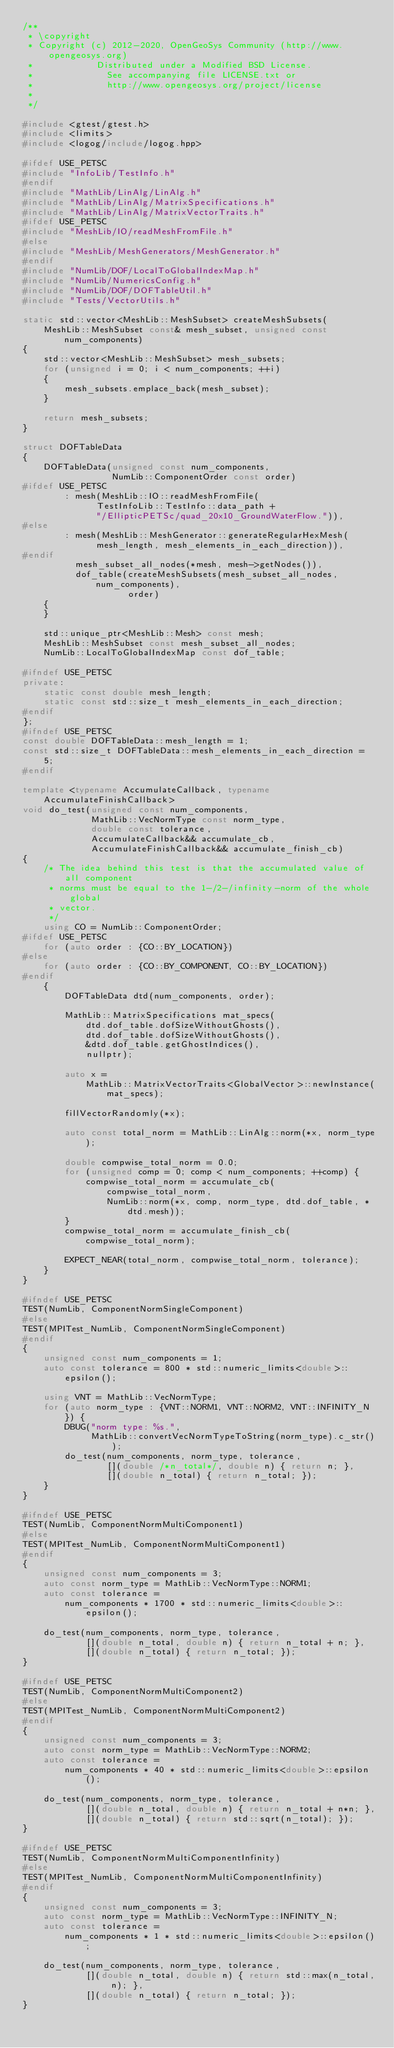<code> <loc_0><loc_0><loc_500><loc_500><_C++_>/**
 * \copyright
 * Copyright (c) 2012-2020, OpenGeoSys Community (http://www.opengeosys.org)
 *            Distributed under a Modified BSD License.
 *              See accompanying file LICENSE.txt or
 *              http://www.opengeosys.org/project/license
 *
 */

#include <gtest/gtest.h>
#include <limits>
#include <logog/include/logog.hpp>

#ifdef USE_PETSC
#include "InfoLib/TestInfo.h"
#endif
#include "MathLib/LinAlg/LinAlg.h"
#include "MathLib/LinAlg/MatrixSpecifications.h"
#include "MathLib/LinAlg/MatrixVectorTraits.h"
#ifdef USE_PETSC
#include "MeshLib/IO/readMeshFromFile.h"
#else
#include "MeshLib/MeshGenerators/MeshGenerator.h"
#endif
#include "NumLib/DOF/LocalToGlobalIndexMap.h"
#include "NumLib/NumericsConfig.h"
#include "NumLib/DOF/DOFTableUtil.h"
#include "Tests/VectorUtils.h"

static std::vector<MeshLib::MeshSubset> createMeshSubsets(
    MeshLib::MeshSubset const& mesh_subset, unsigned const num_components)
{
    std::vector<MeshLib::MeshSubset> mesh_subsets;
    for (unsigned i = 0; i < num_components; ++i)
    {
        mesh_subsets.emplace_back(mesh_subset);
    }

    return mesh_subsets;
}

struct DOFTableData
{
    DOFTableData(unsigned const num_components,
                 NumLib::ComponentOrder const order)
#ifdef USE_PETSC
        : mesh(MeshLib::IO::readMeshFromFile(
              TestInfoLib::TestInfo::data_path +
              "/EllipticPETSc/quad_20x10_GroundWaterFlow.")),
#else
        : mesh(MeshLib::MeshGenerator::generateRegularHexMesh(
              mesh_length, mesh_elements_in_each_direction)),
#endif
          mesh_subset_all_nodes(*mesh, mesh->getNodes()),
          dof_table(createMeshSubsets(mesh_subset_all_nodes, num_components),
                    order)
    {
    }

    std::unique_ptr<MeshLib::Mesh> const mesh;
    MeshLib::MeshSubset const mesh_subset_all_nodes;
    NumLib::LocalToGlobalIndexMap const dof_table;

#ifndef USE_PETSC
private:
    static const double mesh_length;
    static const std::size_t mesh_elements_in_each_direction;
#endif
};
#ifndef USE_PETSC
const double DOFTableData::mesh_length = 1;
const std::size_t DOFTableData::mesh_elements_in_each_direction = 5;
#endif

template <typename AccumulateCallback, typename AccumulateFinishCallback>
void do_test(unsigned const num_components,
             MathLib::VecNormType const norm_type,
             double const tolerance,
             AccumulateCallback&& accumulate_cb,
             AccumulateFinishCallback&& accumulate_finish_cb)
{
    /* The idea behind this test is that the accumulated value of all component
     * norms must be equal to the 1-/2-/infinity-norm of the whole global
     * vector.
     */
    using CO = NumLib::ComponentOrder;
#ifdef USE_PETSC
    for (auto order : {CO::BY_LOCATION})
#else
    for (auto order : {CO::BY_COMPONENT, CO::BY_LOCATION})
#endif
    {
        DOFTableData dtd(num_components, order);

        MathLib::MatrixSpecifications mat_specs(
            dtd.dof_table.dofSizeWithoutGhosts(),
            dtd.dof_table.dofSizeWithoutGhosts(),
            &dtd.dof_table.getGhostIndices(),
            nullptr);

        auto x =
            MathLib::MatrixVectorTraits<GlobalVector>::newInstance(mat_specs);

        fillVectorRandomly(*x);

        auto const total_norm = MathLib::LinAlg::norm(*x, norm_type);

        double compwise_total_norm = 0.0;
        for (unsigned comp = 0; comp < num_components; ++comp) {
            compwise_total_norm = accumulate_cb(
                compwise_total_norm,
                NumLib::norm(*x, comp, norm_type, dtd.dof_table, *dtd.mesh));
        }
        compwise_total_norm = accumulate_finish_cb(compwise_total_norm);

        EXPECT_NEAR(total_norm, compwise_total_norm, tolerance);
    }
}

#ifndef USE_PETSC
TEST(NumLib, ComponentNormSingleComponent)
#else
TEST(MPITest_NumLib, ComponentNormSingleComponent)
#endif
{
    unsigned const num_components = 1;
    auto const tolerance = 800 * std::numeric_limits<double>::epsilon();

    using VNT = MathLib::VecNormType;
    for (auto norm_type : {VNT::NORM1, VNT::NORM2, VNT::INFINITY_N}) {
        DBUG("norm type: %s.",
             MathLib::convertVecNormTypeToString(norm_type).c_str());
        do_test(num_components, norm_type, tolerance,
                [](double /*n_total*/, double n) { return n; },
                [](double n_total) { return n_total; });
    }
}

#ifndef USE_PETSC
TEST(NumLib, ComponentNormMultiComponent1)
#else
TEST(MPITest_NumLib, ComponentNormMultiComponent1)
#endif
{
    unsigned const num_components = 3;
    auto const norm_type = MathLib::VecNormType::NORM1;
    auto const tolerance =
        num_components * 1700 * std::numeric_limits<double>::epsilon();

    do_test(num_components, norm_type, tolerance,
            [](double n_total, double n) { return n_total + n; },
            [](double n_total) { return n_total; });
}

#ifndef USE_PETSC
TEST(NumLib, ComponentNormMultiComponent2)
#else
TEST(MPITest_NumLib, ComponentNormMultiComponent2)
#endif
{
    unsigned const num_components = 3;
    auto const norm_type = MathLib::VecNormType::NORM2;
    auto const tolerance =
        num_components * 40 * std::numeric_limits<double>::epsilon();

    do_test(num_components, norm_type, tolerance,
            [](double n_total, double n) { return n_total + n*n; },
            [](double n_total) { return std::sqrt(n_total); });
}

#ifndef USE_PETSC
TEST(NumLib, ComponentNormMultiComponentInfinity)
#else
TEST(MPITest_NumLib, ComponentNormMultiComponentInfinity)
#endif
{
    unsigned const num_components = 3;
    auto const norm_type = MathLib::VecNormType::INFINITY_N;
    auto const tolerance =
        num_components * 1 * std::numeric_limits<double>::epsilon();

    do_test(num_components, norm_type, tolerance,
            [](double n_total, double n) { return std::max(n_total, n); },
            [](double n_total) { return n_total; });
}
</code> 